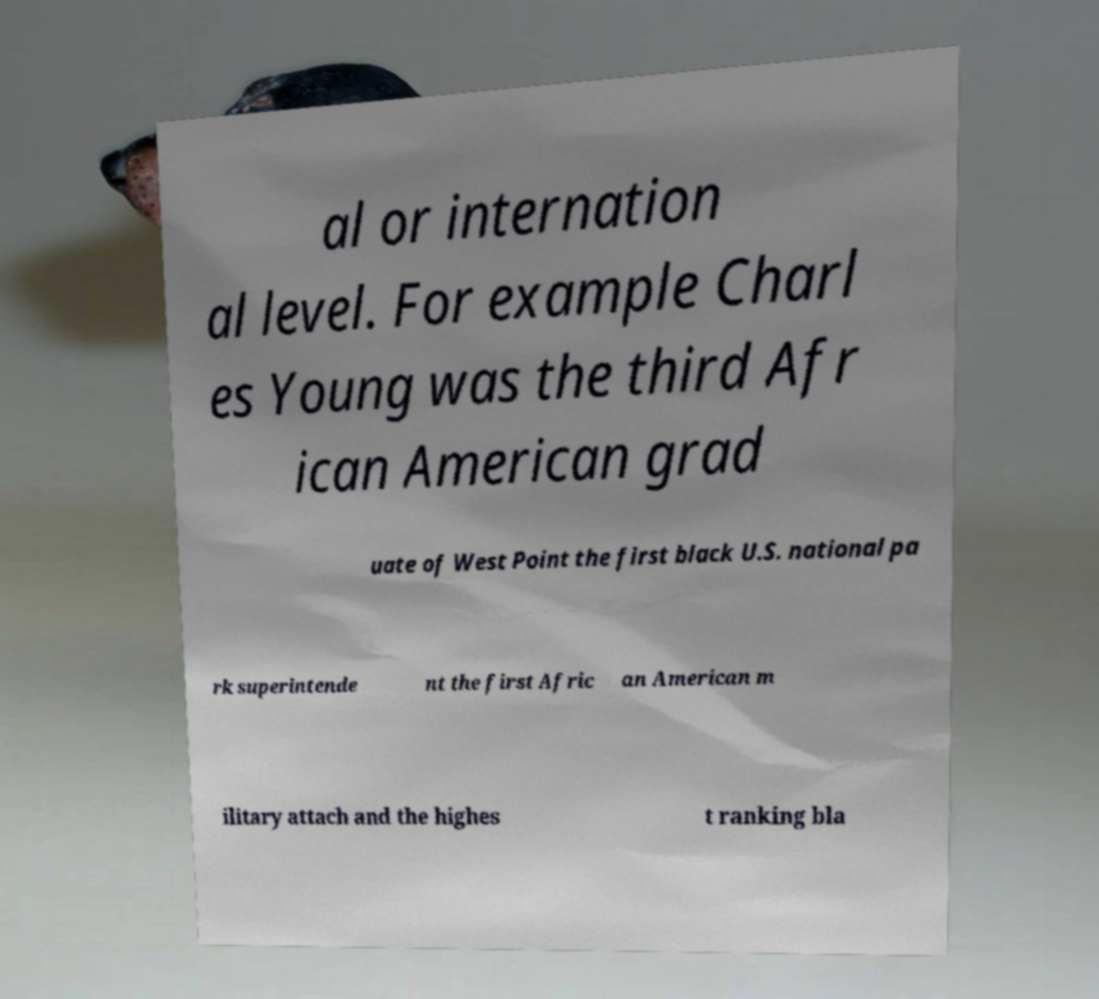For documentation purposes, I need the text within this image transcribed. Could you provide that? al or internation al level. For example Charl es Young was the third Afr ican American grad uate of West Point the first black U.S. national pa rk superintende nt the first Afric an American m ilitary attach and the highes t ranking bla 